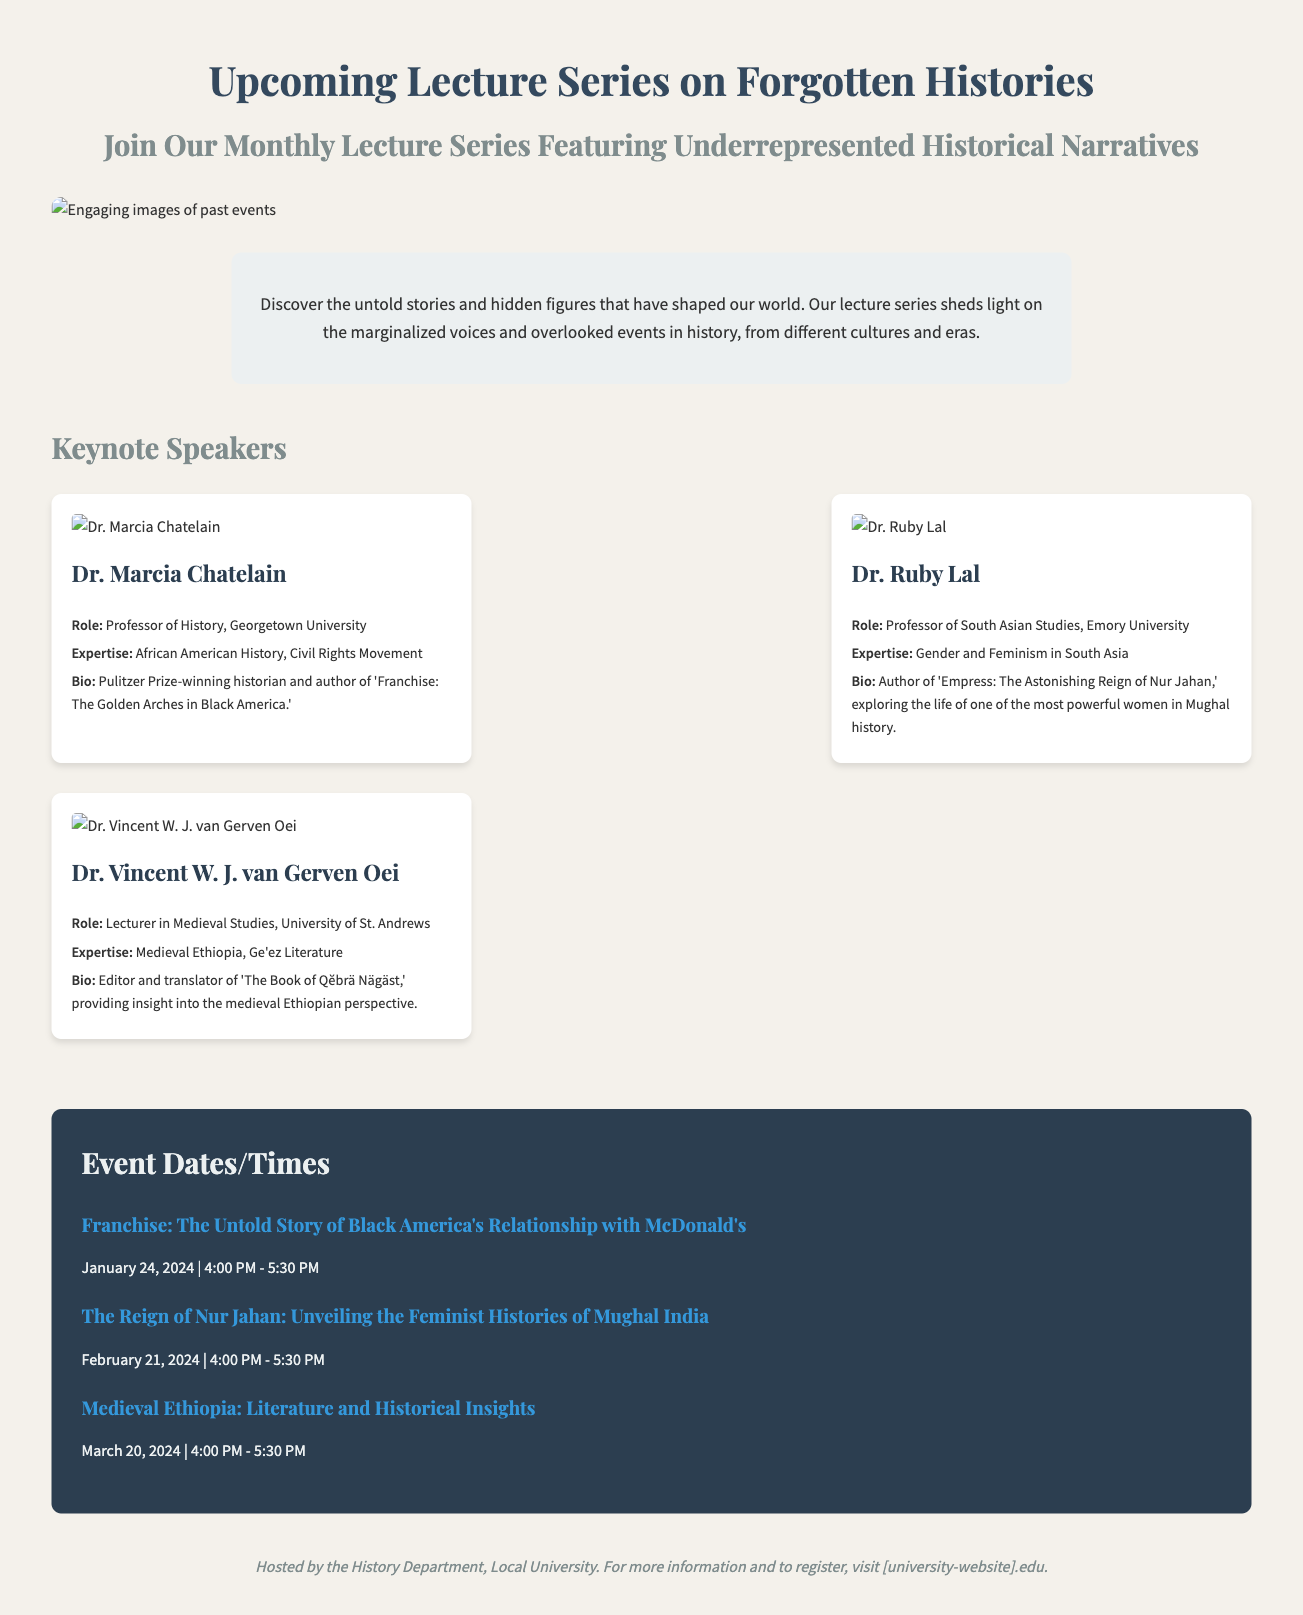What is the title of the lecture series? The title is prominently displayed at the top of the document and is "Upcoming Lecture Series on Forgotten Histories."
Answer: Upcoming Lecture Series on Forgotten Histories Who is the keynote speaker for the event on January 24, 2024? The speaker is identified in the events section with the corresponding event title which is "Franchise: The Untold Story of Black America's Relationship with McDonald's." The associated speaker is Dr. Marcia Chatelain.
Answer: Dr. Marcia Chatelain How many keynote speakers are listed in the document? By counting the speaker sections, the document presents three keynote speakers in total.
Answer: Three What expertise does Dr. Ruby Lal specialize in? The expertise of Dr. Ruby Lal is mentioned in her profile and reads: "Gender and Feminism in South Asia."
Answer: Gender and Feminism in South Asia What type of event is hosted according to the footer of the document? The footer indicates that the event is hosted by the History Department of a local university.
Answer: History Department What is the bio of Dr. Vincent W. J. van Gerven Oei? The bio for Dr. Vincent is provided in his section and describes him as "Editor and translator of 'The Book of Qĕbrä Nägäst,' providing insight into the medieval Ethiopian perspective."
Answer: Editor and translator of 'The Book of Qĕbrä Nägäst' What visual content accompanies the lecture series announcement? The main visual content is an engaging image related to past events that visually represents the theme of the lecture series.
Answer: Engaging images of past events 